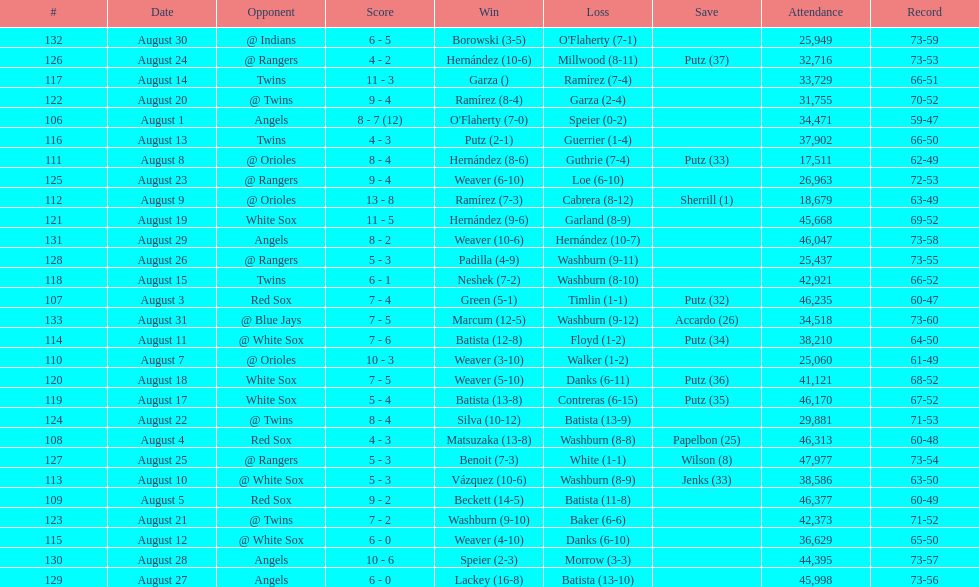Number of wins during stretch 5. 